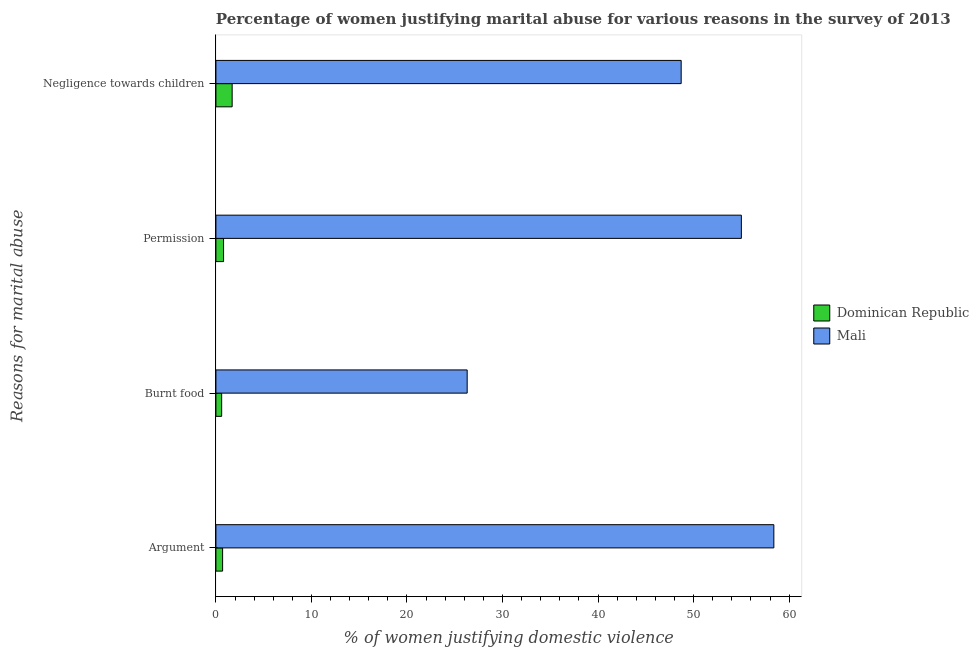How many different coloured bars are there?
Your response must be concise. 2. Are the number of bars per tick equal to the number of legend labels?
Make the answer very short. Yes. How many bars are there on the 1st tick from the bottom?
Make the answer very short. 2. What is the label of the 4th group of bars from the top?
Offer a terse response. Argument. What is the percentage of women justifying abuse for going without permission in Dominican Republic?
Your response must be concise. 0.8. In which country was the percentage of women justifying abuse in the case of an argument maximum?
Offer a terse response. Mali. In which country was the percentage of women justifying abuse for going without permission minimum?
Offer a very short reply. Dominican Republic. What is the total percentage of women justifying abuse for going without permission in the graph?
Offer a terse response. 55.8. What is the difference between the percentage of women justifying abuse for burning food in Dominican Republic and that in Mali?
Keep it short and to the point. -25.7. What is the difference between the percentage of women justifying abuse for showing negligence towards children in Mali and the percentage of women justifying abuse for going without permission in Dominican Republic?
Your answer should be very brief. 47.9. What is the average percentage of women justifying abuse for going without permission per country?
Offer a terse response. 27.9. What is the ratio of the percentage of women justifying abuse in the case of an argument in Mali to that in Dominican Republic?
Your answer should be compact. 83.43. Is the percentage of women justifying abuse for going without permission in Dominican Republic less than that in Mali?
Your response must be concise. Yes. What is the difference between the highest and the second highest percentage of women justifying abuse for showing negligence towards children?
Make the answer very short. 47. In how many countries, is the percentage of women justifying abuse in the case of an argument greater than the average percentage of women justifying abuse in the case of an argument taken over all countries?
Give a very brief answer. 1. Is the sum of the percentage of women justifying abuse for going without permission in Mali and Dominican Republic greater than the maximum percentage of women justifying abuse for burning food across all countries?
Make the answer very short. Yes. Is it the case that in every country, the sum of the percentage of women justifying abuse in the case of an argument and percentage of women justifying abuse for burning food is greater than the sum of percentage of women justifying abuse for going without permission and percentage of women justifying abuse for showing negligence towards children?
Keep it short and to the point. No. What does the 1st bar from the top in Permission represents?
Your answer should be compact. Mali. What does the 1st bar from the bottom in Permission represents?
Offer a very short reply. Dominican Republic. Is it the case that in every country, the sum of the percentage of women justifying abuse in the case of an argument and percentage of women justifying abuse for burning food is greater than the percentage of women justifying abuse for going without permission?
Your response must be concise. Yes. How many bars are there?
Your response must be concise. 8. Are all the bars in the graph horizontal?
Offer a very short reply. Yes. What is the difference between two consecutive major ticks on the X-axis?
Your response must be concise. 10. Does the graph contain any zero values?
Your response must be concise. No. Where does the legend appear in the graph?
Provide a short and direct response. Center right. How are the legend labels stacked?
Your response must be concise. Vertical. What is the title of the graph?
Ensure brevity in your answer.  Percentage of women justifying marital abuse for various reasons in the survey of 2013. What is the label or title of the X-axis?
Give a very brief answer. % of women justifying domestic violence. What is the label or title of the Y-axis?
Your answer should be compact. Reasons for marital abuse. What is the % of women justifying domestic violence in Dominican Republic in Argument?
Provide a short and direct response. 0.7. What is the % of women justifying domestic violence of Mali in Argument?
Keep it short and to the point. 58.4. What is the % of women justifying domestic violence in Dominican Republic in Burnt food?
Your response must be concise. 0.6. What is the % of women justifying domestic violence in Mali in Burnt food?
Your answer should be very brief. 26.3. What is the % of women justifying domestic violence in Dominican Republic in Permission?
Offer a very short reply. 0.8. What is the % of women justifying domestic violence in Dominican Republic in Negligence towards children?
Your response must be concise. 1.7. What is the % of women justifying domestic violence of Mali in Negligence towards children?
Make the answer very short. 48.7. Across all Reasons for marital abuse, what is the maximum % of women justifying domestic violence of Mali?
Your response must be concise. 58.4. Across all Reasons for marital abuse, what is the minimum % of women justifying domestic violence in Mali?
Your answer should be very brief. 26.3. What is the total % of women justifying domestic violence in Mali in the graph?
Your answer should be compact. 188.4. What is the difference between the % of women justifying domestic violence in Dominican Republic in Argument and that in Burnt food?
Your answer should be very brief. 0.1. What is the difference between the % of women justifying domestic violence of Mali in Argument and that in Burnt food?
Provide a short and direct response. 32.1. What is the difference between the % of women justifying domestic violence of Mali in Argument and that in Negligence towards children?
Provide a short and direct response. 9.7. What is the difference between the % of women justifying domestic violence of Dominican Republic in Burnt food and that in Permission?
Provide a short and direct response. -0.2. What is the difference between the % of women justifying domestic violence of Mali in Burnt food and that in Permission?
Provide a short and direct response. -28.7. What is the difference between the % of women justifying domestic violence in Mali in Burnt food and that in Negligence towards children?
Keep it short and to the point. -22.4. What is the difference between the % of women justifying domestic violence of Dominican Republic in Argument and the % of women justifying domestic violence of Mali in Burnt food?
Provide a succinct answer. -25.6. What is the difference between the % of women justifying domestic violence in Dominican Republic in Argument and the % of women justifying domestic violence in Mali in Permission?
Give a very brief answer. -54.3. What is the difference between the % of women justifying domestic violence of Dominican Republic in Argument and the % of women justifying domestic violence of Mali in Negligence towards children?
Provide a succinct answer. -48. What is the difference between the % of women justifying domestic violence in Dominican Republic in Burnt food and the % of women justifying domestic violence in Mali in Permission?
Offer a terse response. -54.4. What is the difference between the % of women justifying domestic violence in Dominican Republic in Burnt food and the % of women justifying domestic violence in Mali in Negligence towards children?
Keep it short and to the point. -48.1. What is the difference between the % of women justifying domestic violence of Dominican Republic in Permission and the % of women justifying domestic violence of Mali in Negligence towards children?
Your answer should be very brief. -47.9. What is the average % of women justifying domestic violence of Mali per Reasons for marital abuse?
Your answer should be very brief. 47.1. What is the difference between the % of women justifying domestic violence in Dominican Republic and % of women justifying domestic violence in Mali in Argument?
Provide a short and direct response. -57.7. What is the difference between the % of women justifying domestic violence in Dominican Republic and % of women justifying domestic violence in Mali in Burnt food?
Provide a short and direct response. -25.7. What is the difference between the % of women justifying domestic violence of Dominican Republic and % of women justifying domestic violence of Mali in Permission?
Keep it short and to the point. -54.2. What is the difference between the % of women justifying domestic violence of Dominican Republic and % of women justifying domestic violence of Mali in Negligence towards children?
Your answer should be very brief. -47. What is the ratio of the % of women justifying domestic violence in Dominican Republic in Argument to that in Burnt food?
Your answer should be very brief. 1.17. What is the ratio of the % of women justifying domestic violence of Mali in Argument to that in Burnt food?
Your answer should be very brief. 2.22. What is the ratio of the % of women justifying domestic violence in Dominican Republic in Argument to that in Permission?
Provide a short and direct response. 0.88. What is the ratio of the % of women justifying domestic violence in Mali in Argument to that in Permission?
Ensure brevity in your answer.  1.06. What is the ratio of the % of women justifying domestic violence in Dominican Republic in Argument to that in Negligence towards children?
Your answer should be compact. 0.41. What is the ratio of the % of women justifying domestic violence of Mali in Argument to that in Negligence towards children?
Ensure brevity in your answer.  1.2. What is the ratio of the % of women justifying domestic violence in Dominican Republic in Burnt food to that in Permission?
Provide a short and direct response. 0.75. What is the ratio of the % of women justifying domestic violence in Mali in Burnt food to that in Permission?
Make the answer very short. 0.48. What is the ratio of the % of women justifying domestic violence of Dominican Republic in Burnt food to that in Negligence towards children?
Your answer should be compact. 0.35. What is the ratio of the % of women justifying domestic violence in Mali in Burnt food to that in Negligence towards children?
Offer a very short reply. 0.54. What is the ratio of the % of women justifying domestic violence of Dominican Republic in Permission to that in Negligence towards children?
Provide a short and direct response. 0.47. What is the ratio of the % of women justifying domestic violence in Mali in Permission to that in Negligence towards children?
Your answer should be very brief. 1.13. What is the difference between the highest and the second highest % of women justifying domestic violence in Mali?
Keep it short and to the point. 3.4. What is the difference between the highest and the lowest % of women justifying domestic violence in Dominican Republic?
Offer a terse response. 1.1. What is the difference between the highest and the lowest % of women justifying domestic violence of Mali?
Ensure brevity in your answer.  32.1. 